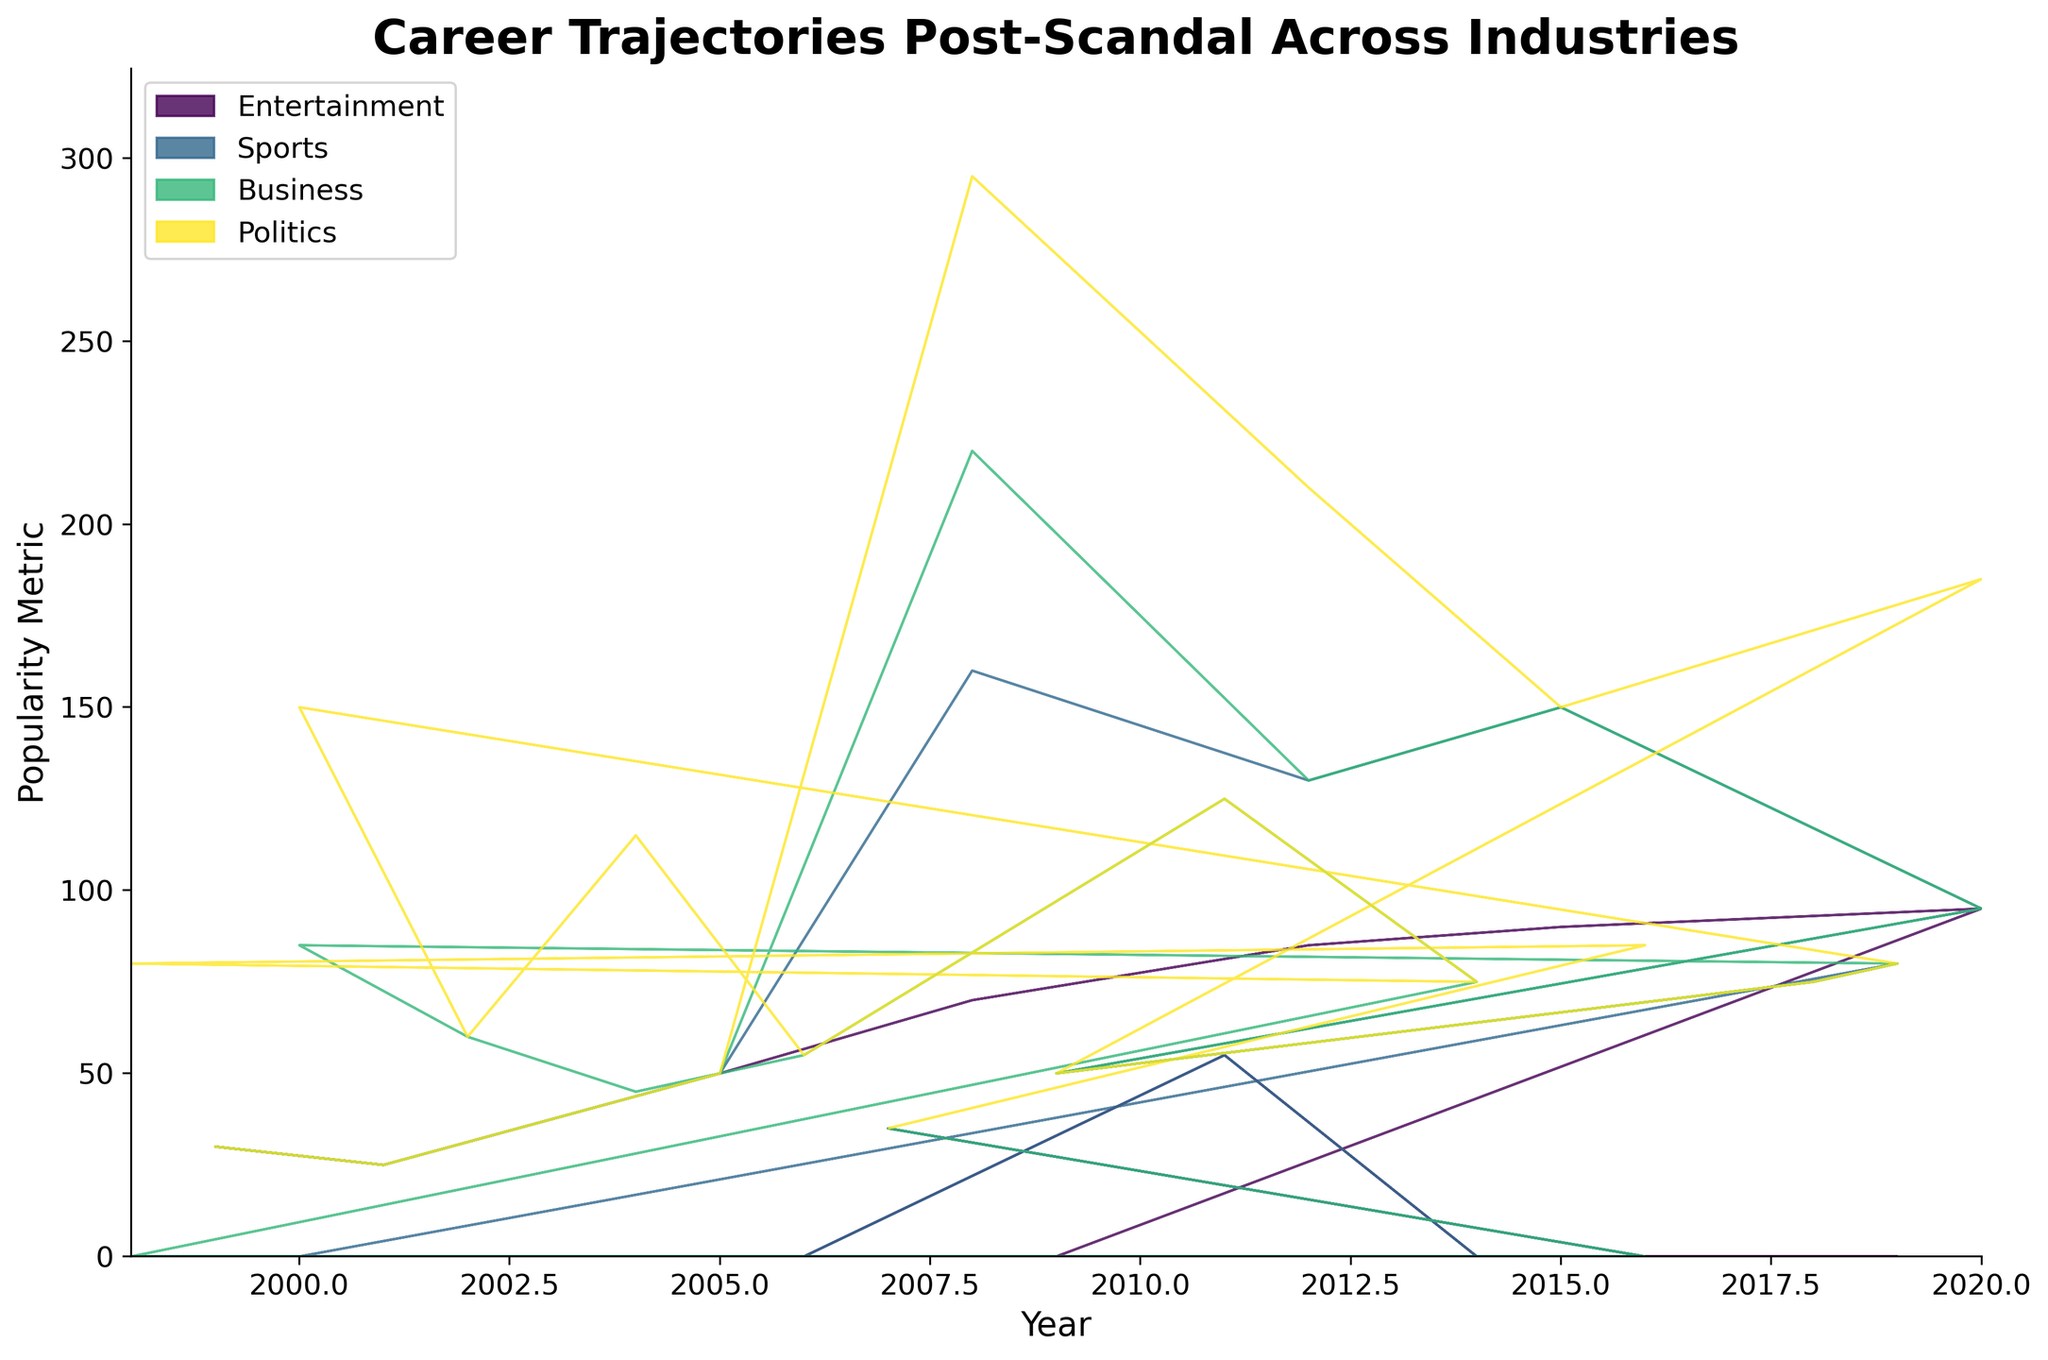What's the title of the graph? The title of the graph is usually found at the top of the plot and provides a summary of what the figure represents.
Answer: Career Trajectories Post-Scandal Across Industries How many industries are represented in the graph? The number of different colors in the stream graph, each representing a distinct industry, corresponds to the number of unique industries.
Answer: 4 Which entity showed the most improvement in popularity over the years? To determine the entity with the most improvement, look at the individual trajectories and see which one exhibits the steepest increase over time. Robert Downey Jr.'s popularity shows a significant increase.
Answer: Robert Downey Jr Which year did Tiger Woods experience the lowest popularity metric? By observing Tiger Woods's trajectory within the Sports industry section of the graph, you can pinpoint the lowest point in his curve.
Answer: 2012 In which industry did popularity metrics show the most fluctuation over time? To identify the industry with the most fluctuation, look at which color band has the most irregular and varied shape.
Answer: Sports Which individual reached a popularity metric of 95 in 2020? Trace the year 2020 on the x-axis and look at the corresponding popularity metrics on the y-axis; identify the individual associated with the highest peak in that year.
Answer: Robert Downey Jr Which industry consistently maintained a stable increase in popularity over the years? Look for a smoothly increasing trajectory without sharp drops or irregularities across the years.
Answer: Politics Between 2015 and 2020, which individual in the Entertainment industry had the highest increase in popularity? Compare the slopes of the lines within the Entertainment section between these years to determine which one increased the most.
Answer: Britney Spears What's the average popularity metric of Martha Stewart between 2000 and 2014? Sum up Martha Stewart’s popularity metrics for the specified years, and then divide by the number of years (6 in this instance) to find the average.
Answer: (85 + 60 + 45 + 55 + 60 + 70 + 75) / 7 = 64.3 Compare Bill Clinton's popularity in 2008 to 2012. Which year saw higher popularity? Locate the points for Bill Clinton in the years 2008 and 2012, and compare the heights of those points to determine which is higher.
Answer: 2012 